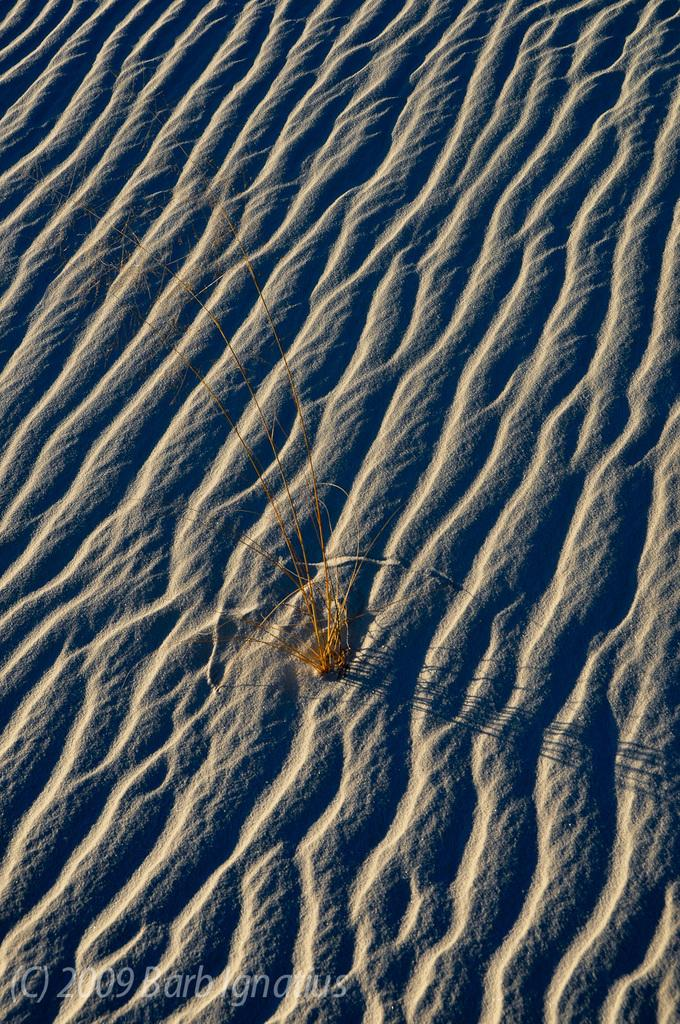What is the main subject in the center of the image? There is a plant in the center of the image. What type of terrain can be seen in the background of the image? There is sand in the background of the image. Is there any text present in the image? Yes, there is text at the bottom of the image. What type of lock is used to secure the crown in the image? There is no lock or crown present in the image; it features a plant and sandy background with text at the bottom. 